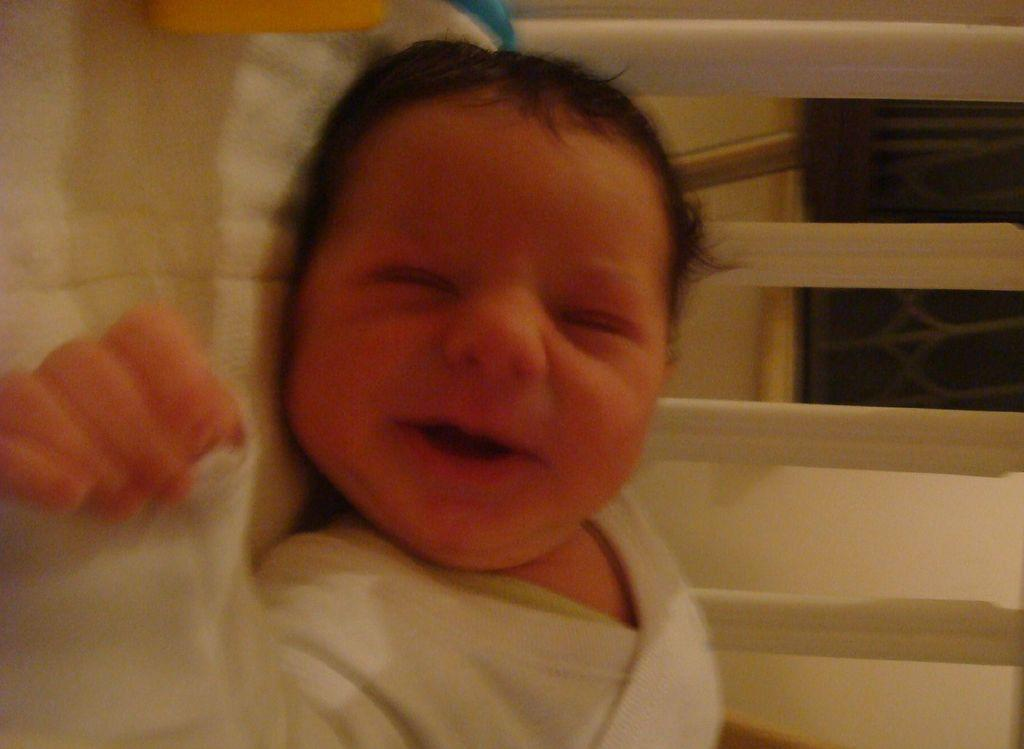What is the main subject of the image? There is a baby lying on a bed in the image. What can be seen in the background of the image? There is a wooden fence and a window visible in the background of the image. How many toes can be seen on the baby's foot in the image? There is no visible foot or toes of the baby in the image. What type of rake is being used by the baby in the image? There is no rake present in the image; the baby is lying on a bed. 